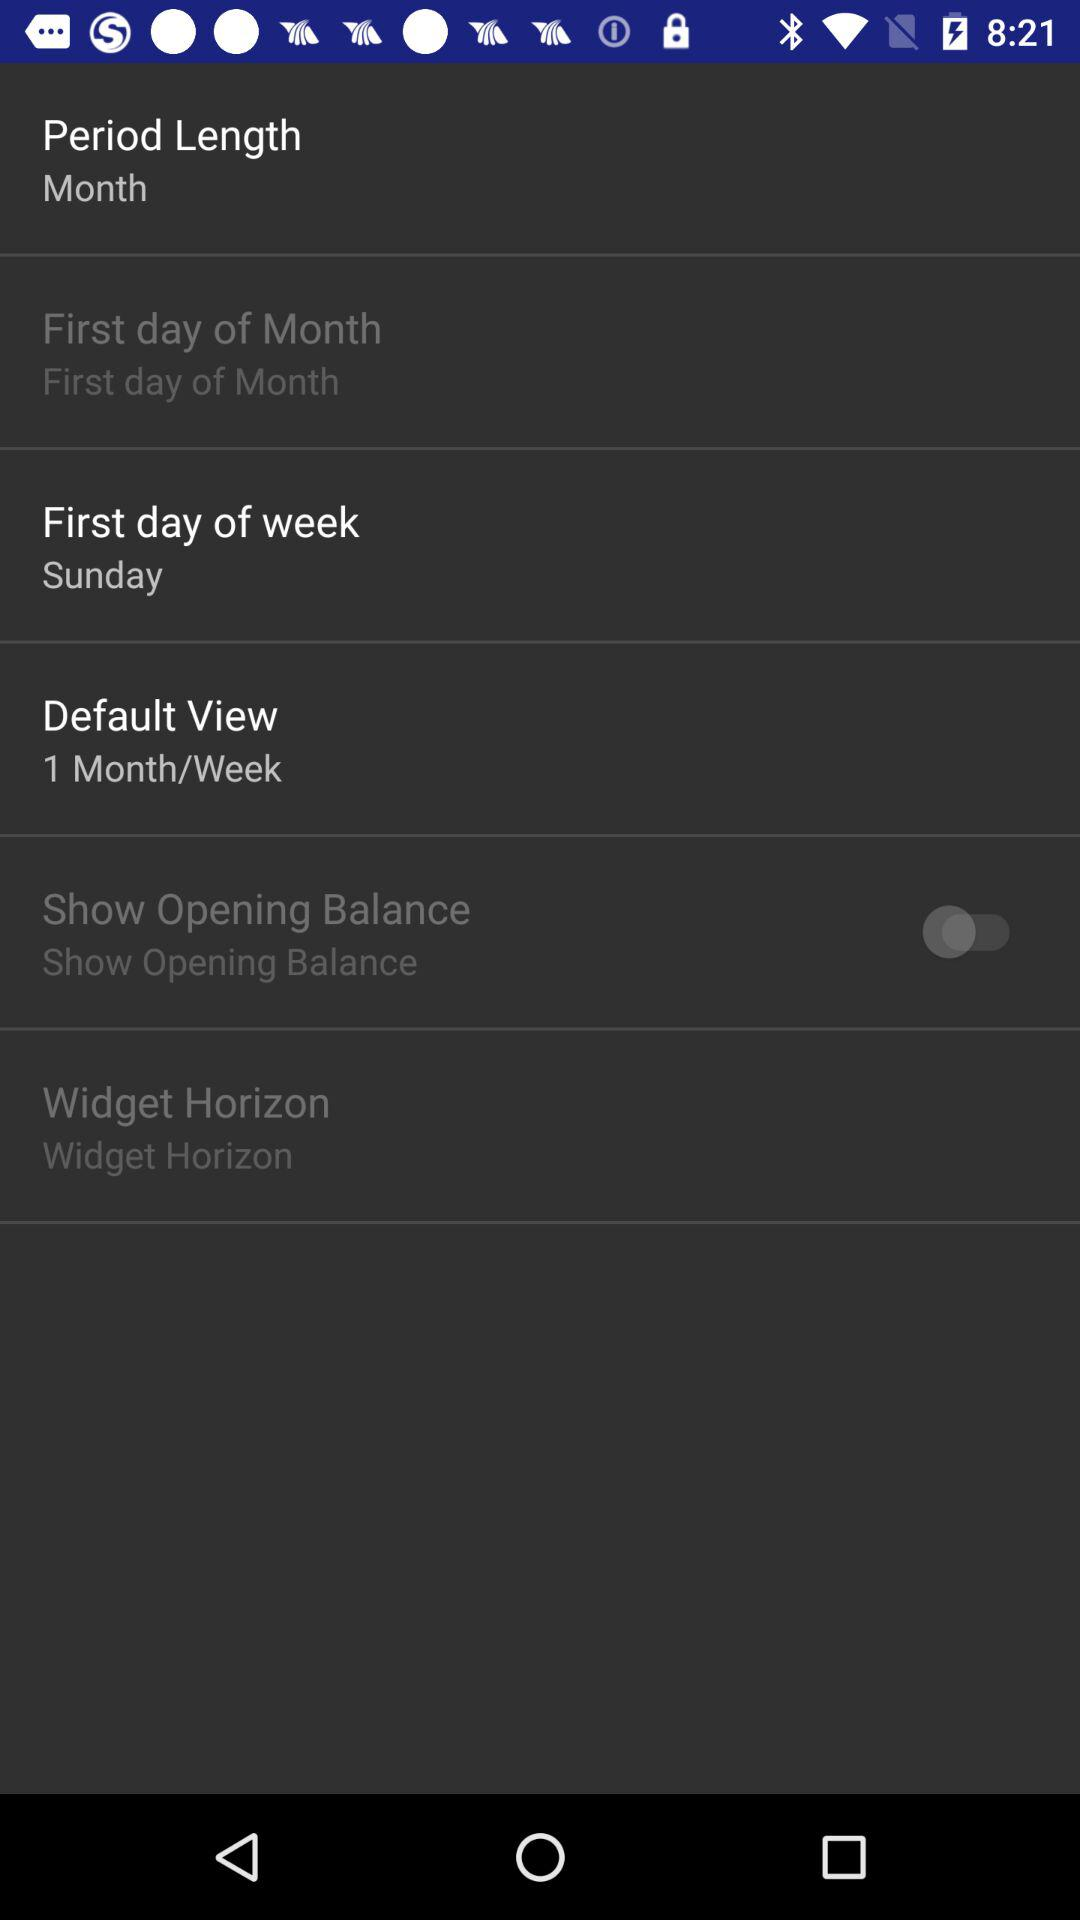What is the default view? The default view is "1 Month/Week". 